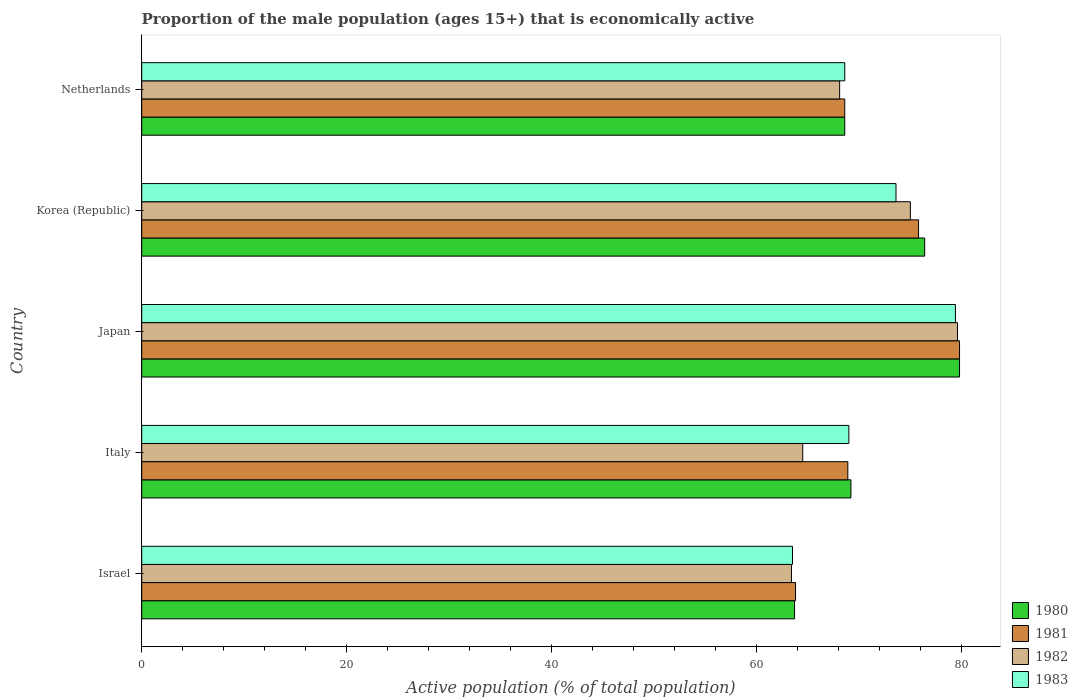How many different coloured bars are there?
Give a very brief answer. 4. Are the number of bars on each tick of the Y-axis equal?
Your answer should be compact. Yes. How many bars are there on the 2nd tick from the top?
Ensure brevity in your answer.  4. What is the label of the 3rd group of bars from the top?
Make the answer very short. Japan. What is the proportion of the male population that is economically active in 1980 in Japan?
Your answer should be very brief. 79.8. Across all countries, what is the maximum proportion of the male population that is economically active in 1980?
Your answer should be compact. 79.8. Across all countries, what is the minimum proportion of the male population that is economically active in 1981?
Your response must be concise. 63.8. In which country was the proportion of the male population that is economically active in 1981 maximum?
Keep it short and to the point. Japan. In which country was the proportion of the male population that is economically active in 1982 minimum?
Your response must be concise. Israel. What is the total proportion of the male population that is economically active in 1983 in the graph?
Offer a terse response. 354.1. What is the difference between the proportion of the male population that is economically active in 1982 in Korea (Republic) and that in Netherlands?
Your answer should be very brief. 6.9. What is the difference between the proportion of the male population that is economically active in 1981 in Italy and the proportion of the male population that is economically active in 1983 in Netherlands?
Keep it short and to the point. 0.3. What is the average proportion of the male population that is economically active in 1981 per country?
Your answer should be compact. 71.38. What is the difference between the proportion of the male population that is economically active in 1982 and proportion of the male population that is economically active in 1983 in Korea (Republic)?
Ensure brevity in your answer.  1.4. In how many countries, is the proportion of the male population that is economically active in 1981 greater than 56 %?
Keep it short and to the point. 5. What is the ratio of the proportion of the male population that is economically active in 1981 in Italy to that in Japan?
Your answer should be compact. 0.86. Is the proportion of the male population that is economically active in 1983 in Italy less than that in Korea (Republic)?
Offer a very short reply. Yes. Is the difference between the proportion of the male population that is economically active in 1982 in Italy and Netherlands greater than the difference between the proportion of the male population that is economically active in 1983 in Italy and Netherlands?
Offer a terse response. No. What is the difference between the highest and the lowest proportion of the male population that is economically active in 1982?
Your answer should be very brief. 16.2. Is the sum of the proportion of the male population that is economically active in 1982 in Italy and Japan greater than the maximum proportion of the male population that is economically active in 1980 across all countries?
Ensure brevity in your answer.  Yes. How many bars are there?
Your answer should be compact. 20. How many countries are there in the graph?
Make the answer very short. 5. Where does the legend appear in the graph?
Keep it short and to the point. Bottom right. What is the title of the graph?
Offer a terse response. Proportion of the male population (ages 15+) that is economically active. What is the label or title of the X-axis?
Offer a very short reply. Active population (% of total population). What is the Active population (% of total population) in 1980 in Israel?
Keep it short and to the point. 63.7. What is the Active population (% of total population) of 1981 in Israel?
Give a very brief answer. 63.8. What is the Active population (% of total population) of 1982 in Israel?
Make the answer very short. 63.4. What is the Active population (% of total population) in 1983 in Israel?
Your response must be concise. 63.5. What is the Active population (% of total population) in 1980 in Italy?
Offer a terse response. 69.2. What is the Active population (% of total population) of 1981 in Italy?
Provide a succinct answer. 68.9. What is the Active population (% of total population) of 1982 in Italy?
Your response must be concise. 64.5. What is the Active population (% of total population) in 1983 in Italy?
Keep it short and to the point. 69. What is the Active population (% of total population) of 1980 in Japan?
Ensure brevity in your answer.  79.8. What is the Active population (% of total population) of 1981 in Japan?
Ensure brevity in your answer.  79.8. What is the Active population (% of total population) in 1982 in Japan?
Ensure brevity in your answer.  79.6. What is the Active population (% of total population) in 1983 in Japan?
Your answer should be very brief. 79.4. What is the Active population (% of total population) in 1980 in Korea (Republic)?
Offer a very short reply. 76.4. What is the Active population (% of total population) of 1981 in Korea (Republic)?
Your response must be concise. 75.8. What is the Active population (% of total population) of 1982 in Korea (Republic)?
Provide a short and direct response. 75. What is the Active population (% of total population) of 1983 in Korea (Republic)?
Provide a succinct answer. 73.6. What is the Active population (% of total population) of 1980 in Netherlands?
Keep it short and to the point. 68.6. What is the Active population (% of total population) in 1981 in Netherlands?
Give a very brief answer. 68.6. What is the Active population (% of total population) in 1982 in Netherlands?
Offer a very short reply. 68.1. What is the Active population (% of total population) of 1983 in Netherlands?
Offer a very short reply. 68.6. Across all countries, what is the maximum Active population (% of total population) in 1980?
Give a very brief answer. 79.8. Across all countries, what is the maximum Active population (% of total population) of 1981?
Ensure brevity in your answer.  79.8. Across all countries, what is the maximum Active population (% of total population) of 1982?
Keep it short and to the point. 79.6. Across all countries, what is the maximum Active population (% of total population) of 1983?
Your answer should be compact. 79.4. Across all countries, what is the minimum Active population (% of total population) in 1980?
Provide a succinct answer. 63.7. Across all countries, what is the minimum Active population (% of total population) of 1981?
Your response must be concise. 63.8. Across all countries, what is the minimum Active population (% of total population) in 1982?
Offer a terse response. 63.4. Across all countries, what is the minimum Active population (% of total population) in 1983?
Ensure brevity in your answer.  63.5. What is the total Active population (% of total population) in 1980 in the graph?
Ensure brevity in your answer.  357.7. What is the total Active population (% of total population) in 1981 in the graph?
Your answer should be very brief. 356.9. What is the total Active population (% of total population) in 1982 in the graph?
Offer a very short reply. 350.6. What is the total Active population (% of total population) of 1983 in the graph?
Your answer should be very brief. 354.1. What is the difference between the Active population (% of total population) of 1981 in Israel and that in Italy?
Your response must be concise. -5.1. What is the difference between the Active population (% of total population) in 1983 in Israel and that in Italy?
Provide a succinct answer. -5.5. What is the difference between the Active population (% of total population) in 1980 in Israel and that in Japan?
Provide a short and direct response. -16.1. What is the difference between the Active population (% of total population) of 1981 in Israel and that in Japan?
Your answer should be very brief. -16. What is the difference between the Active population (% of total population) in 1982 in Israel and that in Japan?
Provide a succinct answer. -16.2. What is the difference between the Active population (% of total population) of 1983 in Israel and that in Japan?
Ensure brevity in your answer.  -15.9. What is the difference between the Active population (% of total population) of 1980 in Israel and that in Korea (Republic)?
Offer a very short reply. -12.7. What is the difference between the Active population (% of total population) in 1982 in Italy and that in Japan?
Your answer should be very brief. -15.1. What is the difference between the Active population (% of total population) in 1983 in Italy and that in Japan?
Keep it short and to the point. -10.4. What is the difference between the Active population (% of total population) of 1980 in Italy and that in Korea (Republic)?
Make the answer very short. -7.2. What is the difference between the Active population (% of total population) of 1981 in Italy and that in Korea (Republic)?
Provide a short and direct response. -6.9. What is the difference between the Active population (% of total population) in 1983 in Italy and that in Korea (Republic)?
Provide a succinct answer. -4.6. What is the difference between the Active population (% of total population) in 1983 in Italy and that in Netherlands?
Offer a terse response. 0.4. What is the difference between the Active population (% of total population) of 1980 in Japan and that in Korea (Republic)?
Offer a terse response. 3.4. What is the difference between the Active population (% of total population) of 1981 in Japan and that in Korea (Republic)?
Provide a succinct answer. 4. What is the difference between the Active population (% of total population) of 1982 in Japan and that in Korea (Republic)?
Provide a succinct answer. 4.6. What is the difference between the Active population (% of total population) of 1980 in Japan and that in Netherlands?
Your answer should be very brief. 11.2. What is the difference between the Active population (% of total population) of 1982 in Japan and that in Netherlands?
Provide a succinct answer. 11.5. What is the difference between the Active population (% of total population) in 1980 in Korea (Republic) and that in Netherlands?
Offer a terse response. 7.8. What is the difference between the Active population (% of total population) of 1980 in Israel and the Active population (% of total population) of 1981 in Japan?
Give a very brief answer. -16.1. What is the difference between the Active population (% of total population) of 1980 in Israel and the Active population (% of total population) of 1982 in Japan?
Your answer should be very brief. -15.9. What is the difference between the Active population (% of total population) of 1980 in Israel and the Active population (% of total population) of 1983 in Japan?
Offer a terse response. -15.7. What is the difference between the Active population (% of total population) in 1981 in Israel and the Active population (% of total population) in 1982 in Japan?
Your answer should be very brief. -15.8. What is the difference between the Active population (% of total population) in 1981 in Israel and the Active population (% of total population) in 1983 in Japan?
Give a very brief answer. -15.6. What is the difference between the Active population (% of total population) of 1982 in Israel and the Active population (% of total population) of 1983 in Japan?
Ensure brevity in your answer.  -16. What is the difference between the Active population (% of total population) in 1980 in Israel and the Active population (% of total population) in 1982 in Korea (Republic)?
Offer a very short reply. -11.3. What is the difference between the Active population (% of total population) of 1980 in Israel and the Active population (% of total population) of 1983 in Korea (Republic)?
Make the answer very short. -9.9. What is the difference between the Active population (% of total population) in 1981 in Israel and the Active population (% of total population) in 1982 in Korea (Republic)?
Your response must be concise. -11.2. What is the difference between the Active population (% of total population) in 1981 in Israel and the Active population (% of total population) in 1983 in Korea (Republic)?
Offer a very short reply. -9.8. What is the difference between the Active population (% of total population) in 1982 in Israel and the Active population (% of total population) in 1983 in Korea (Republic)?
Your answer should be very brief. -10.2. What is the difference between the Active population (% of total population) of 1980 in Israel and the Active population (% of total population) of 1982 in Netherlands?
Offer a terse response. -4.4. What is the difference between the Active population (% of total population) of 1980 in Israel and the Active population (% of total population) of 1983 in Netherlands?
Give a very brief answer. -4.9. What is the difference between the Active population (% of total population) in 1981 in Israel and the Active population (% of total population) in 1983 in Netherlands?
Your answer should be very brief. -4.8. What is the difference between the Active population (% of total population) in 1980 in Italy and the Active population (% of total population) in 1981 in Japan?
Provide a succinct answer. -10.6. What is the difference between the Active population (% of total population) in 1980 in Italy and the Active population (% of total population) in 1983 in Japan?
Provide a succinct answer. -10.2. What is the difference between the Active population (% of total population) of 1981 in Italy and the Active population (% of total population) of 1982 in Japan?
Provide a short and direct response. -10.7. What is the difference between the Active population (% of total population) of 1981 in Italy and the Active population (% of total population) of 1983 in Japan?
Provide a succinct answer. -10.5. What is the difference between the Active population (% of total population) in 1982 in Italy and the Active population (% of total population) in 1983 in Japan?
Your answer should be compact. -14.9. What is the difference between the Active population (% of total population) in 1980 in Italy and the Active population (% of total population) in 1982 in Korea (Republic)?
Offer a terse response. -5.8. What is the difference between the Active population (% of total population) of 1980 in Italy and the Active population (% of total population) of 1983 in Korea (Republic)?
Your answer should be compact. -4.4. What is the difference between the Active population (% of total population) of 1981 in Italy and the Active population (% of total population) of 1982 in Korea (Republic)?
Ensure brevity in your answer.  -6.1. What is the difference between the Active population (% of total population) in 1982 in Italy and the Active population (% of total population) in 1983 in Korea (Republic)?
Your answer should be compact. -9.1. What is the difference between the Active population (% of total population) in 1980 in Italy and the Active population (% of total population) in 1981 in Netherlands?
Give a very brief answer. 0.6. What is the difference between the Active population (% of total population) in 1980 in Italy and the Active population (% of total population) in 1982 in Netherlands?
Give a very brief answer. 1.1. What is the difference between the Active population (% of total population) of 1981 in Italy and the Active population (% of total population) of 1982 in Netherlands?
Offer a terse response. 0.8. What is the difference between the Active population (% of total population) of 1981 in Italy and the Active population (% of total population) of 1983 in Netherlands?
Give a very brief answer. 0.3. What is the difference between the Active population (% of total population) in 1980 in Japan and the Active population (% of total population) in 1981 in Korea (Republic)?
Ensure brevity in your answer.  4. What is the difference between the Active population (% of total population) in 1980 in Japan and the Active population (% of total population) in 1982 in Korea (Republic)?
Ensure brevity in your answer.  4.8. What is the difference between the Active population (% of total population) in 1980 in Japan and the Active population (% of total population) in 1983 in Korea (Republic)?
Give a very brief answer. 6.2. What is the difference between the Active population (% of total population) of 1982 in Japan and the Active population (% of total population) of 1983 in Korea (Republic)?
Offer a terse response. 6. What is the difference between the Active population (% of total population) of 1980 in Japan and the Active population (% of total population) of 1982 in Netherlands?
Keep it short and to the point. 11.7. What is the difference between the Active population (% of total population) in 1981 in Japan and the Active population (% of total population) in 1983 in Netherlands?
Offer a terse response. 11.2. What is the difference between the Active population (% of total population) of 1982 in Japan and the Active population (% of total population) of 1983 in Netherlands?
Keep it short and to the point. 11. What is the difference between the Active population (% of total population) in 1980 in Korea (Republic) and the Active population (% of total population) in 1981 in Netherlands?
Give a very brief answer. 7.8. What is the difference between the Active population (% of total population) in 1980 in Korea (Republic) and the Active population (% of total population) in 1983 in Netherlands?
Offer a terse response. 7.8. What is the difference between the Active population (% of total population) in 1981 in Korea (Republic) and the Active population (% of total population) in 1982 in Netherlands?
Your response must be concise. 7.7. What is the average Active population (% of total population) in 1980 per country?
Provide a succinct answer. 71.54. What is the average Active population (% of total population) of 1981 per country?
Your answer should be compact. 71.38. What is the average Active population (% of total population) in 1982 per country?
Make the answer very short. 70.12. What is the average Active population (% of total population) in 1983 per country?
Your response must be concise. 70.82. What is the difference between the Active population (% of total population) in 1980 and Active population (% of total population) in 1981 in Israel?
Your answer should be compact. -0.1. What is the difference between the Active population (% of total population) of 1980 and Active population (% of total population) of 1982 in Israel?
Your response must be concise. 0.3. What is the difference between the Active population (% of total population) of 1980 and Active population (% of total population) of 1983 in Israel?
Your response must be concise. 0.2. What is the difference between the Active population (% of total population) in 1982 and Active population (% of total population) in 1983 in Israel?
Provide a short and direct response. -0.1. What is the difference between the Active population (% of total population) of 1982 and Active population (% of total population) of 1983 in Italy?
Provide a succinct answer. -4.5. What is the difference between the Active population (% of total population) in 1980 and Active population (% of total population) in 1982 in Japan?
Make the answer very short. 0.2. What is the difference between the Active population (% of total population) of 1980 and Active population (% of total population) of 1983 in Japan?
Provide a succinct answer. 0.4. What is the difference between the Active population (% of total population) of 1981 and Active population (% of total population) of 1982 in Japan?
Provide a short and direct response. 0.2. What is the difference between the Active population (% of total population) in 1980 and Active population (% of total population) in 1981 in Korea (Republic)?
Keep it short and to the point. 0.6. What is the difference between the Active population (% of total population) of 1980 and Active population (% of total population) of 1983 in Korea (Republic)?
Provide a short and direct response. 2.8. What is the difference between the Active population (% of total population) of 1981 and Active population (% of total population) of 1982 in Korea (Republic)?
Offer a terse response. 0.8. What is the difference between the Active population (% of total population) in 1982 and Active population (% of total population) in 1983 in Korea (Republic)?
Keep it short and to the point. 1.4. What is the difference between the Active population (% of total population) of 1980 and Active population (% of total population) of 1981 in Netherlands?
Your answer should be compact. 0. What is the difference between the Active population (% of total population) of 1980 and Active population (% of total population) of 1982 in Netherlands?
Make the answer very short. 0.5. What is the difference between the Active population (% of total population) of 1981 and Active population (% of total population) of 1983 in Netherlands?
Your response must be concise. 0. What is the ratio of the Active population (% of total population) in 1980 in Israel to that in Italy?
Your answer should be compact. 0.92. What is the ratio of the Active population (% of total population) of 1981 in Israel to that in Italy?
Give a very brief answer. 0.93. What is the ratio of the Active population (% of total population) of 1982 in Israel to that in Italy?
Ensure brevity in your answer.  0.98. What is the ratio of the Active population (% of total population) in 1983 in Israel to that in Italy?
Offer a terse response. 0.92. What is the ratio of the Active population (% of total population) of 1980 in Israel to that in Japan?
Your answer should be very brief. 0.8. What is the ratio of the Active population (% of total population) in 1981 in Israel to that in Japan?
Give a very brief answer. 0.8. What is the ratio of the Active population (% of total population) in 1982 in Israel to that in Japan?
Provide a succinct answer. 0.8. What is the ratio of the Active population (% of total population) in 1983 in Israel to that in Japan?
Provide a short and direct response. 0.8. What is the ratio of the Active population (% of total population) in 1980 in Israel to that in Korea (Republic)?
Ensure brevity in your answer.  0.83. What is the ratio of the Active population (% of total population) in 1981 in Israel to that in Korea (Republic)?
Give a very brief answer. 0.84. What is the ratio of the Active population (% of total population) of 1982 in Israel to that in Korea (Republic)?
Offer a terse response. 0.85. What is the ratio of the Active population (% of total population) in 1983 in Israel to that in Korea (Republic)?
Your answer should be compact. 0.86. What is the ratio of the Active population (% of total population) of 1980 in Israel to that in Netherlands?
Your response must be concise. 0.93. What is the ratio of the Active population (% of total population) of 1982 in Israel to that in Netherlands?
Your answer should be compact. 0.93. What is the ratio of the Active population (% of total population) of 1983 in Israel to that in Netherlands?
Your answer should be very brief. 0.93. What is the ratio of the Active population (% of total population) of 1980 in Italy to that in Japan?
Offer a terse response. 0.87. What is the ratio of the Active population (% of total population) in 1981 in Italy to that in Japan?
Offer a very short reply. 0.86. What is the ratio of the Active population (% of total population) of 1982 in Italy to that in Japan?
Provide a succinct answer. 0.81. What is the ratio of the Active population (% of total population) in 1983 in Italy to that in Japan?
Give a very brief answer. 0.87. What is the ratio of the Active population (% of total population) of 1980 in Italy to that in Korea (Republic)?
Ensure brevity in your answer.  0.91. What is the ratio of the Active population (% of total population) of 1981 in Italy to that in Korea (Republic)?
Offer a very short reply. 0.91. What is the ratio of the Active population (% of total population) in 1982 in Italy to that in Korea (Republic)?
Offer a terse response. 0.86. What is the ratio of the Active population (% of total population) of 1983 in Italy to that in Korea (Republic)?
Provide a succinct answer. 0.94. What is the ratio of the Active population (% of total population) in 1980 in Italy to that in Netherlands?
Your answer should be very brief. 1.01. What is the ratio of the Active population (% of total population) of 1981 in Italy to that in Netherlands?
Provide a succinct answer. 1. What is the ratio of the Active population (% of total population) in 1982 in Italy to that in Netherlands?
Give a very brief answer. 0.95. What is the ratio of the Active population (% of total population) in 1980 in Japan to that in Korea (Republic)?
Your answer should be compact. 1.04. What is the ratio of the Active population (% of total population) in 1981 in Japan to that in Korea (Republic)?
Give a very brief answer. 1.05. What is the ratio of the Active population (% of total population) in 1982 in Japan to that in Korea (Republic)?
Your response must be concise. 1.06. What is the ratio of the Active population (% of total population) of 1983 in Japan to that in Korea (Republic)?
Offer a very short reply. 1.08. What is the ratio of the Active population (% of total population) of 1980 in Japan to that in Netherlands?
Offer a very short reply. 1.16. What is the ratio of the Active population (% of total population) in 1981 in Japan to that in Netherlands?
Your response must be concise. 1.16. What is the ratio of the Active population (% of total population) of 1982 in Japan to that in Netherlands?
Provide a succinct answer. 1.17. What is the ratio of the Active population (% of total population) of 1983 in Japan to that in Netherlands?
Ensure brevity in your answer.  1.16. What is the ratio of the Active population (% of total population) in 1980 in Korea (Republic) to that in Netherlands?
Ensure brevity in your answer.  1.11. What is the ratio of the Active population (% of total population) of 1981 in Korea (Republic) to that in Netherlands?
Ensure brevity in your answer.  1.1. What is the ratio of the Active population (% of total population) of 1982 in Korea (Republic) to that in Netherlands?
Offer a terse response. 1.1. What is the ratio of the Active population (% of total population) in 1983 in Korea (Republic) to that in Netherlands?
Offer a very short reply. 1.07. What is the difference between the highest and the second highest Active population (% of total population) of 1983?
Make the answer very short. 5.8. What is the difference between the highest and the lowest Active population (% of total population) in 1981?
Your response must be concise. 16. What is the difference between the highest and the lowest Active population (% of total population) of 1982?
Your response must be concise. 16.2. What is the difference between the highest and the lowest Active population (% of total population) of 1983?
Your answer should be very brief. 15.9. 